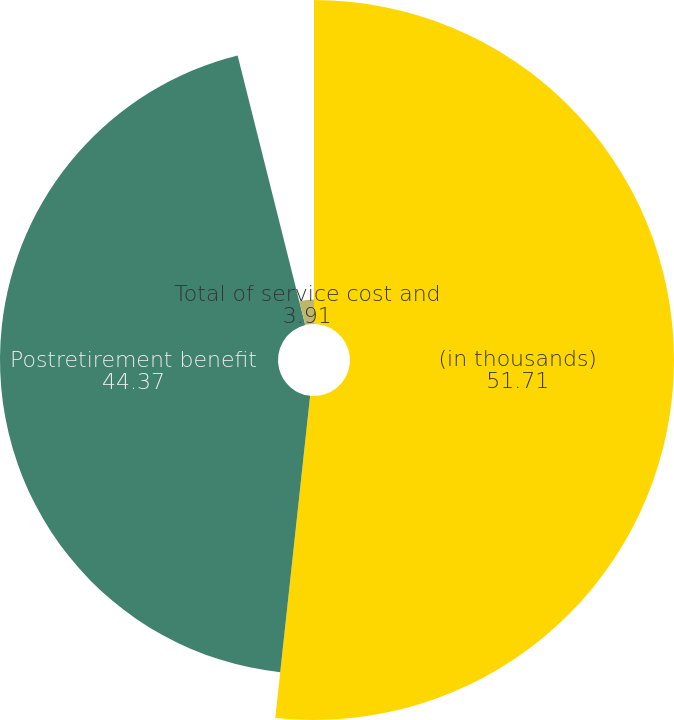Convert chart. <chart><loc_0><loc_0><loc_500><loc_500><pie_chart><fcel>(in thousands)<fcel>Postretirement benefit<fcel>Total of service cost and<nl><fcel>51.71%<fcel>44.37%<fcel>3.91%<nl></chart> 